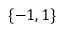<formula> <loc_0><loc_0><loc_500><loc_500>\{ - 1 , 1 \}</formula> 